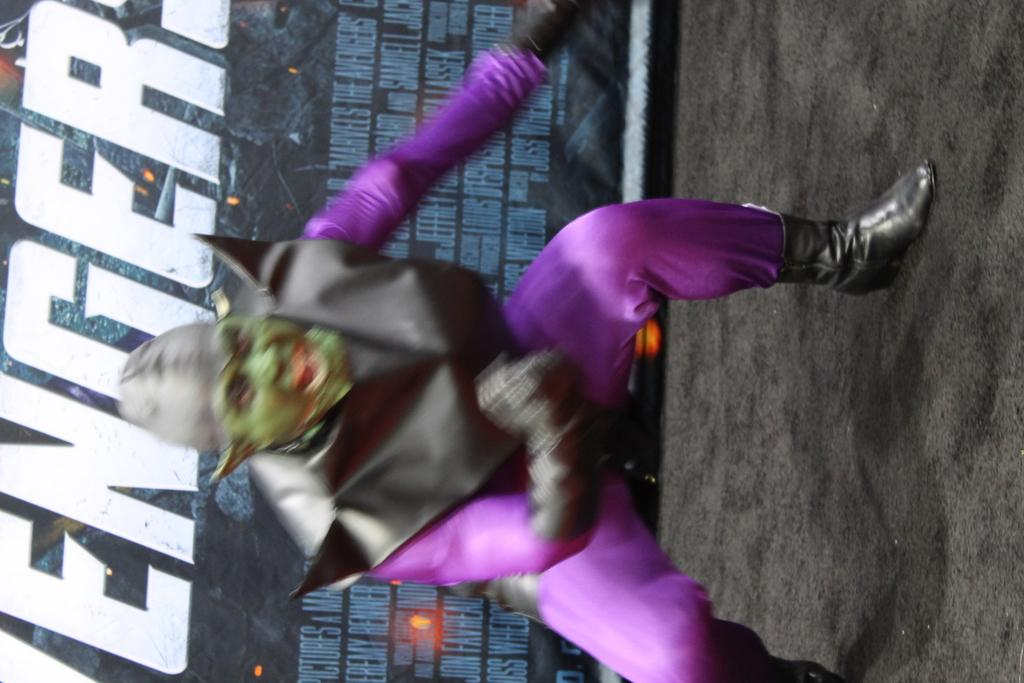What is the person in the image doing? The person is in a cosplay and is standing on the floor. What might the person be expressing in the image? The person is shouting something, which suggests they might be expressing excitement or enthusiasm. What else can be seen in the image besides the person? There is a banner present in the image. What type of pancake is the person holding in the image? There is no pancake present in the image; the person is in a cosplay and standing on the floor. Can you see a rifle in the image? No, there is no rifle present in the image. 